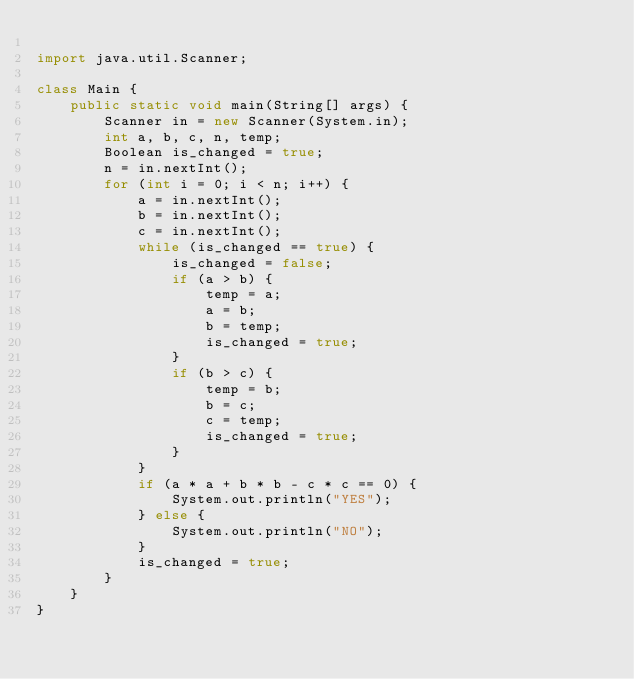<code> <loc_0><loc_0><loc_500><loc_500><_Java_>
import java.util.Scanner;

class Main {
	public static void main(String[] args) {
		Scanner in = new Scanner(System.in);
		int a, b, c, n, temp;
		Boolean is_changed = true;
		n = in.nextInt();
		for (int i = 0; i < n; i++) {
			a = in.nextInt();
			b = in.nextInt();
			c = in.nextInt();
			while (is_changed == true) {
				is_changed = false;
				if (a > b) {
					temp = a;
					a = b;
					b = temp;
					is_changed = true;
				}
				if (b > c) {
					temp = b;
					b = c;
					c = temp;
					is_changed = true;
				}
			}
			if (a * a + b * b - c * c == 0) {
				System.out.println("YES");
			} else {
				System.out.println("NO");
			}
			is_changed = true;
		}
	}
}</code> 